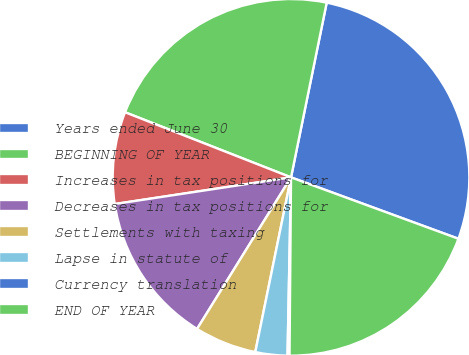Convert chart to OTSL. <chart><loc_0><loc_0><loc_500><loc_500><pie_chart><fcel>Years ended June 30<fcel>BEGINNING OF YEAR<fcel>Increases in tax positions for<fcel>Decreases in tax positions for<fcel>Settlements with taxing<fcel>Lapse in statute of<fcel>Currency translation<fcel>END OF YEAR<nl><fcel>27.39%<fcel>22.26%<fcel>8.34%<fcel>13.78%<fcel>5.62%<fcel>2.9%<fcel>0.18%<fcel>19.54%<nl></chart> 